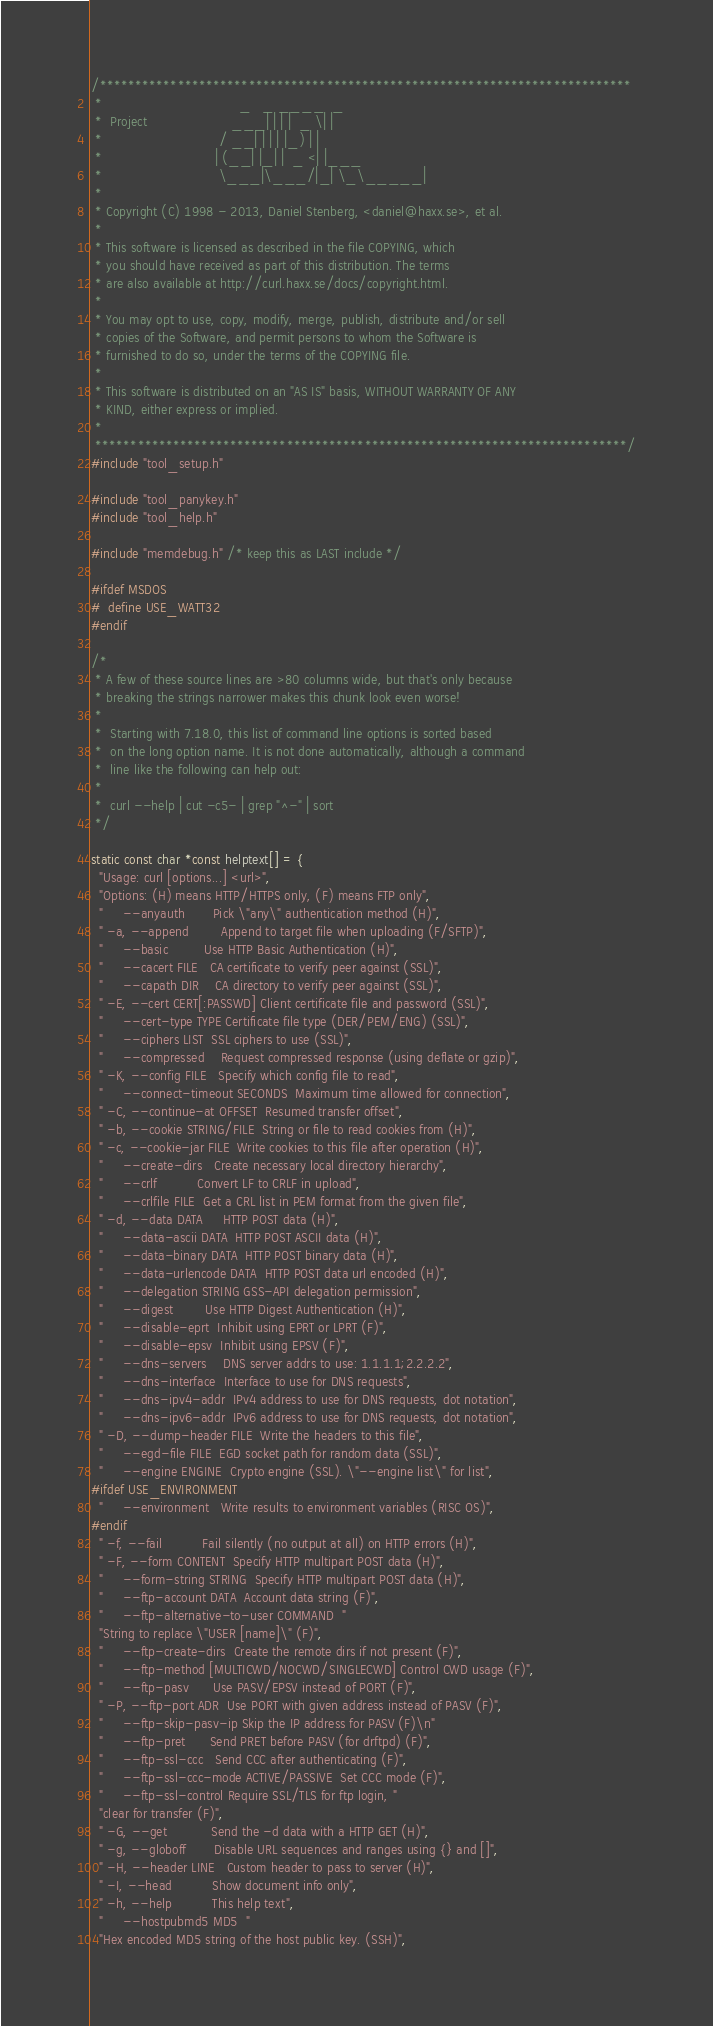Convert code to text. <code><loc_0><loc_0><loc_500><loc_500><_C_>/***************************************************************************
 *                                  _   _ ____  _
 *  Project                     ___| | | |  _ \| |
 *                             / __| | | | |_) | |
 *                            | (__| |_| |  _ <| |___
 *                             \___|\___/|_| \_\_____|
 *
 * Copyright (C) 1998 - 2013, Daniel Stenberg, <daniel@haxx.se>, et al.
 *
 * This software is licensed as described in the file COPYING, which
 * you should have received as part of this distribution. The terms
 * are also available at http://curl.haxx.se/docs/copyright.html.
 *
 * You may opt to use, copy, modify, merge, publish, distribute and/or sell
 * copies of the Software, and permit persons to whom the Software is
 * furnished to do so, under the terms of the COPYING file.
 *
 * This software is distributed on an "AS IS" basis, WITHOUT WARRANTY OF ANY
 * KIND, either express or implied.
 *
 ***************************************************************************/
#include "tool_setup.h"

#include "tool_panykey.h"
#include "tool_help.h"

#include "memdebug.h" /* keep this as LAST include */

#ifdef MSDOS
#  define USE_WATT32
#endif

/*
 * A few of these source lines are >80 columns wide, but that's only because
 * breaking the strings narrower makes this chunk look even worse!
 *
 *  Starting with 7.18.0, this list of command line options is sorted based
 *  on the long option name. It is not done automatically, although a command
 *  line like the following can help out:
 *
 *  curl --help | cut -c5- | grep "^-" | sort
 */

static const char *const helptext[] = {
  "Usage: curl [options...] <url>",
  "Options: (H) means HTTP/HTTPS only, (F) means FTP only",
  "     --anyauth       Pick \"any\" authentication method (H)",
  " -a, --append        Append to target file when uploading (F/SFTP)",
  "     --basic         Use HTTP Basic Authentication (H)",
  "     --cacert FILE   CA certificate to verify peer against (SSL)",
  "     --capath DIR    CA directory to verify peer against (SSL)",
  " -E, --cert CERT[:PASSWD] Client certificate file and password (SSL)",
  "     --cert-type TYPE Certificate file type (DER/PEM/ENG) (SSL)",
  "     --ciphers LIST  SSL ciphers to use (SSL)",
  "     --compressed    Request compressed response (using deflate or gzip)",
  " -K, --config FILE   Specify which config file to read",
  "     --connect-timeout SECONDS  Maximum time allowed for connection",
  " -C, --continue-at OFFSET  Resumed transfer offset",
  " -b, --cookie STRING/FILE  String or file to read cookies from (H)",
  " -c, --cookie-jar FILE  Write cookies to this file after operation (H)",
  "     --create-dirs   Create necessary local directory hierarchy",
  "     --crlf          Convert LF to CRLF in upload",
  "     --crlfile FILE  Get a CRL list in PEM format from the given file",
  " -d, --data DATA     HTTP POST data (H)",
  "     --data-ascii DATA  HTTP POST ASCII data (H)",
  "     --data-binary DATA  HTTP POST binary data (H)",
  "     --data-urlencode DATA  HTTP POST data url encoded (H)",
  "     --delegation STRING GSS-API delegation permission",
  "     --digest        Use HTTP Digest Authentication (H)",
  "     --disable-eprt  Inhibit using EPRT or LPRT (F)",
  "     --disable-epsv  Inhibit using EPSV (F)",
  "     --dns-servers    DNS server addrs to use: 1.1.1.1;2.2.2.2",
  "     --dns-interface  Interface to use for DNS requests",
  "     --dns-ipv4-addr  IPv4 address to use for DNS requests, dot notation",
  "     --dns-ipv6-addr  IPv6 address to use for DNS requests, dot notation",
  " -D, --dump-header FILE  Write the headers to this file",
  "     --egd-file FILE  EGD socket path for random data (SSL)",
  "     --engine ENGINE  Crypto engine (SSL). \"--engine list\" for list",
#ifdef USE_ENVIRONMENT
  "     --environment   Write results to environment variables (RISC OS)",
#endif
  " -f, --fail          Fail silently (no output at all) on HTTP errors (H)",
  " -F, --form CONTENT  Specify HTTP multipart POST data (H)",
  "     --form-string STRING  Specify HTTP multipart POST data (H)",
  "     --ftp-account DATA  Account data string (F)",
  "     --ftp-alternative-to-user COMMAND  "
  "String to replace \"USER [name]\" (F)",
  "     --ftp-create-dirs  Create the remote dirs if not present (F)",
  "     --ftp-method [MULTICWD/NOCWD/SINGLECWD] Control CWD usage (F)",
  "     --ftp-pasv      Use PASV/EPSV instead of PORT (F)",
  " -P, --ftp-port ADR  Use PORT with given address instead of PASV (F)",
  "     --ftp-skip-pasv-ip Skip the IP address for PASV (F)\n"
  "     --ftp-pret      Send PRET before PASV (for drftpd) (F)",
  "     --ftp-ssl-ccc   Send CCC after authenticating (F)",
  "     --ftp-ssl-ccc-mode ACTIVE/PASSIVE  Set CCC mode (F)",
  "     --ftp-ssl-control Require SSL/TLS for ftp login, "
  "clear for transfer (F)",
  " -G, --get           Send the -d data with a HTTP GET (H)",
  " -g, --globoff       Disable URL sequences and ranges using {} and []",
  " -H, --header LINE   Custom header to pass to server (H)",
  " -I, --head          Show document info only",
  " -h, --help          This help text",
  "     --hostpubmd5 MD5  "
  "Hex encoded MD5 string of the host public key. (SSH)",</code> 